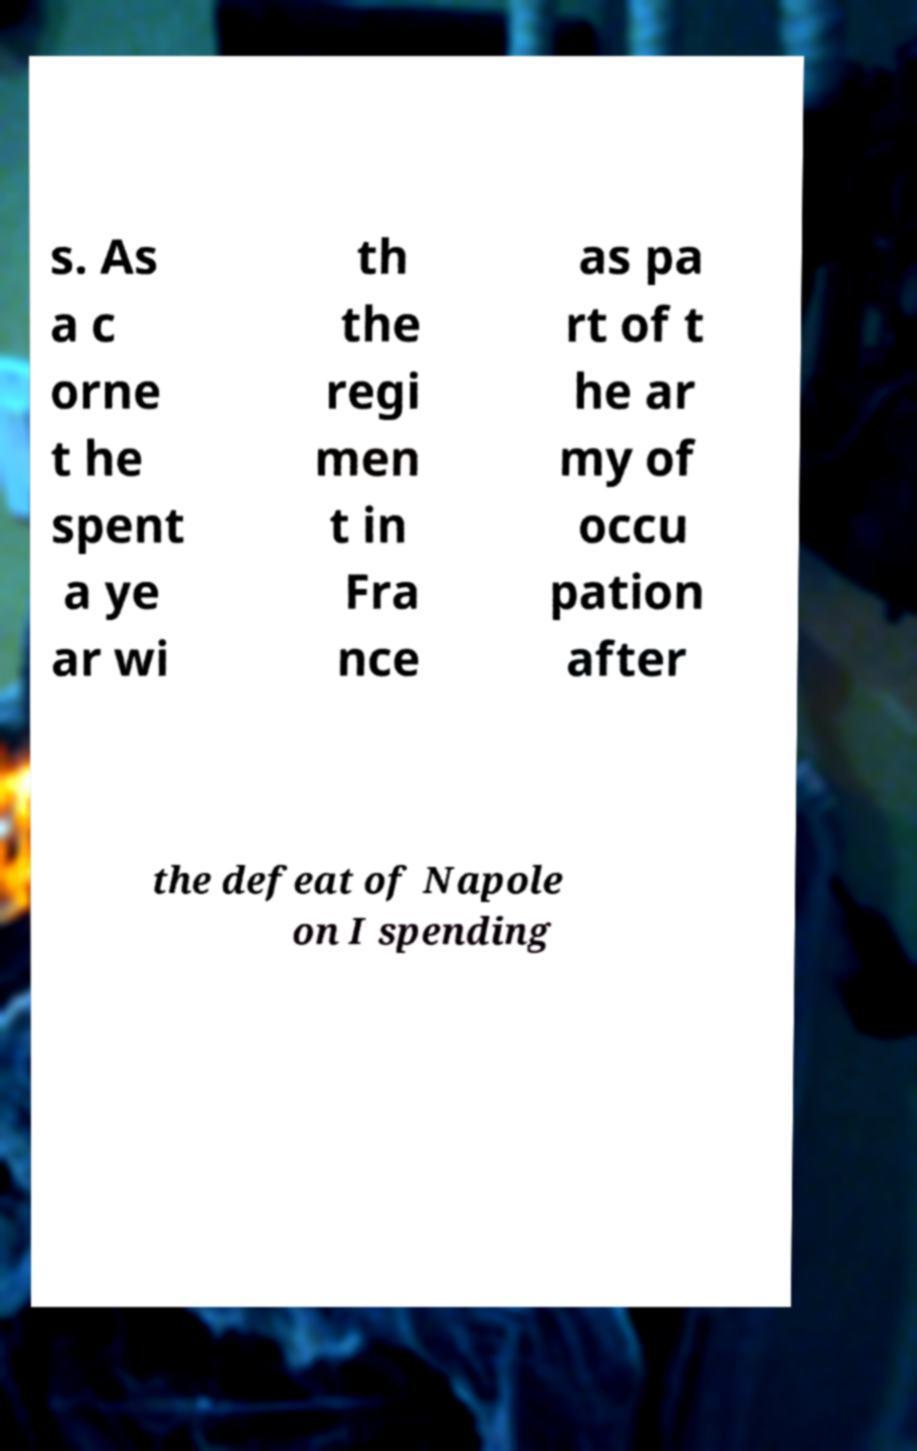Could you extract and type out the text from this image? s. As a c orne t he spent a ye ar wi th the regi men t in Fra nce as pa rt of t he ar my of occu pation after the defeat of Napole on I spending 